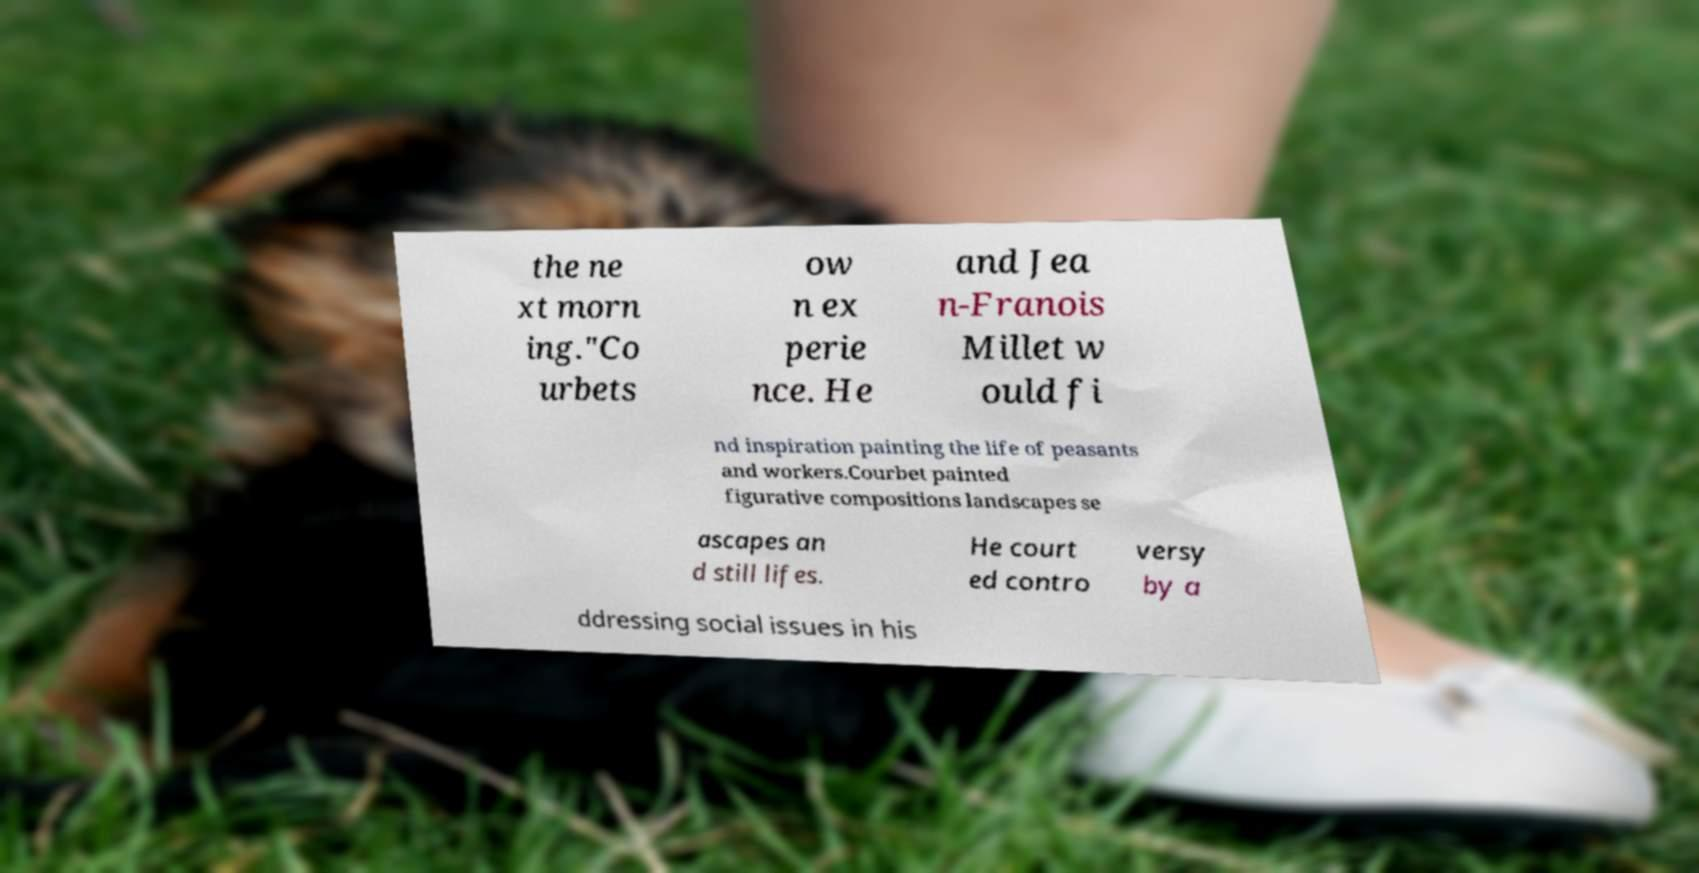There's text embedded in this image that I need extracted. Can you transcribe it verbatim? the ne xt morn ing."Co urbets ow n ex perie nce. He and Jea n-Franois Millet w ould fi nd inspiration painting the life of peasants and workers.Courbet painted figurative compositions landscapes se ascapes an d still lifes. He court ed contro versy by a ddressing social issues in his 